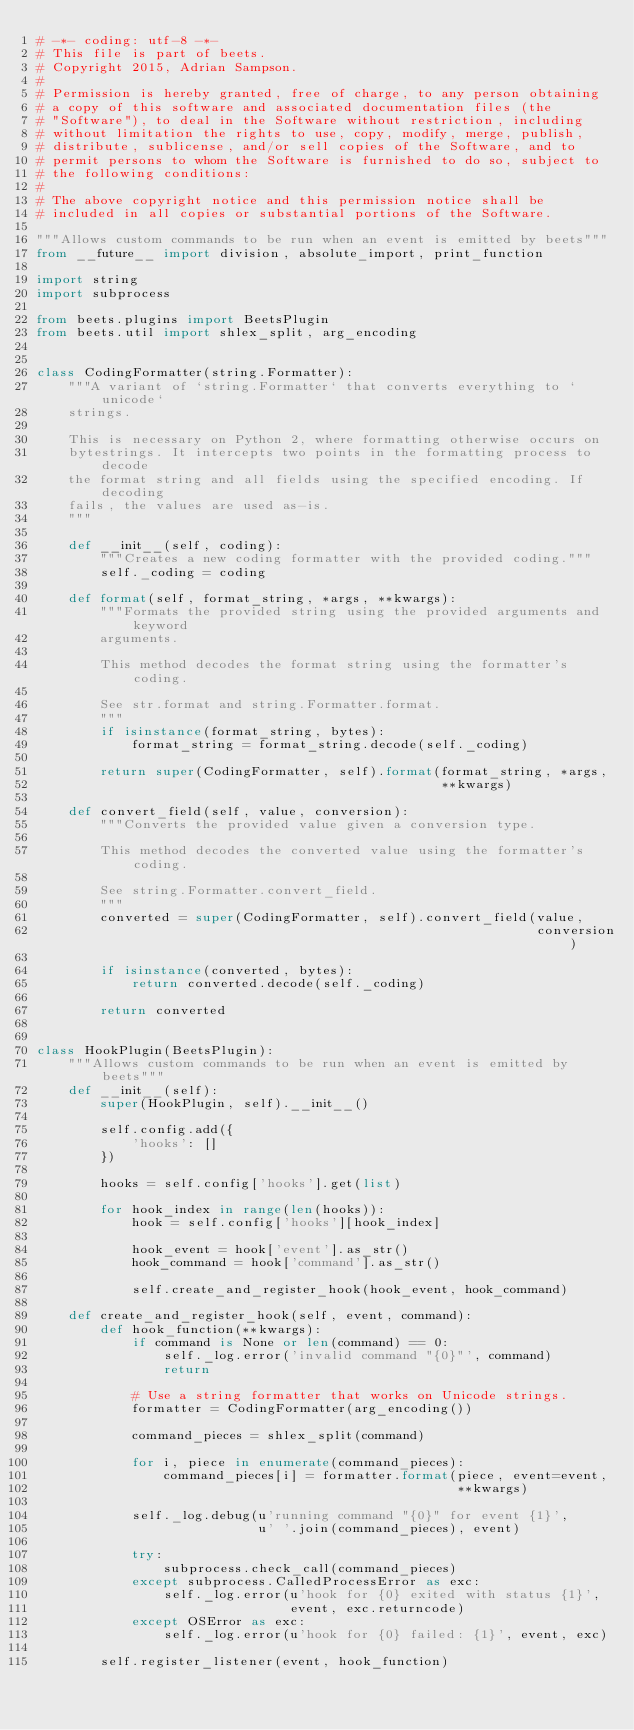Convert code to text. <code><loc_0><loc_0><loc_500><loc_500><_Python_># -*- coding: utf-8 -*-
# This file is part of beets.
# Copyright 2015, Adrian Sampson.
#
# Permission is hereby granted, free of charge, to any person obtaining
# a copy of this software and associated documentation files (the
# "Software"), to deal in the Software without restriction, including
# without limitation the rights to use, copy, modify, merge, publish,
# distribute, sublicense, and/or sell copies of the Software, and to
# permit persons to whom the Software is furnished to do so, subject to
# the following conditions:
#
# The above copyright notice and this permission notice shall be
# included in all copies or substantial portions of the Software.

"""Allows custom commands to be run when an event is emitted by beets"""
from __future__ import division, absolute_import, print_function

import string
import subprocess

from beets.plugins import BeetsPlugin
from beets.util import shlex_split, arg_encoding


class CodingFormatter(string.Formatter):
    """A variant of `string.Formatter` that converts everything to `unicode`
    strings.

    This is necessary on Python 2, where formatting otherwise occurs on
    bytestrings. It intercepts two points in the formatting process to decode
    the format string and all fields using the specified encoding. If decoding
    fails, the values are used as-is.
    """

    def __init__(self, coding):
        """Creates a new coding formatter with the provided coding."""
        self._coding = coding

    def format(self, format_string, *args, **kwargs):
        """Formats the provided string using the provided arguments and keyword
        arguments.

        This method decodes the format string using the formatter's coding.

        See str.format and string.Formatter.format.
        """
        if isinstance(format_string, bytes):
            format_string = format_string.decode(self._coding)

        return super(CodingFormatter, self).format(format_string, *args,
                                                   **kwargs)

    def convert_field(self, value, conversion):
        """Converts the provided value given a conversion type.

        This method decodes the converted value using the formatter's coding.

        See string.Formatter.convert_field.
        """
        converted = super(CodingFormatter, self).convert_field(value,
                                                               conversion)

        if isinstance(converted, bytes):
            return converted.decode(self._coding)

        return converted


class HookPlugin(BeetsPlugin):
    """Allows custom commands to be run when an event is emitted by beets"""
    def __init__(self):
        super(HookPlugin, self).__init__()

        self.config.add({
            'hooks': []
        })

        hooks = self.config['hooks'].get(list)

        for hook_index in range(len(hooks)):
            hook = self.config['hooks'][hook_index]

            hook_event = hook['event'].as_str()
            hook_command = hook['command'].as_str()

            self.create_and_register_hook(hook_event, hook_command)

    def create_and_register_hook(self, event, command):
        def hook_function(**kwargs):
            if command is None or len(command) == 0:
                self._log.error('invalid command "{0}"', command)
                return

            # Use a string formatter that works on Unicode strings.
            formatter = CodingFormatter(arg_encoding())

            command_pieces = shlex_split(command)

            for i, piece in enumerate(command_pieces):
                command_pieces[i] = formatter.format(piece, event=event,
                                                     **kwargs)

            self._log.debug(u'running command "{0}" for event {1}',
                            u' '.join(command_pieces), event)

            try:
                subprocess.check_call(command_pieces)
            except subprocess.CalledProcessError as exc:
                self._log.error(u'hook for {0} exited with status {1}',
                                event, exc.returncode)
            except OSError as exc:
                self._log.error(u'hook for {0} failed: {1}', event, exc)

        self.register_listener(event, hook_function)
</code> 